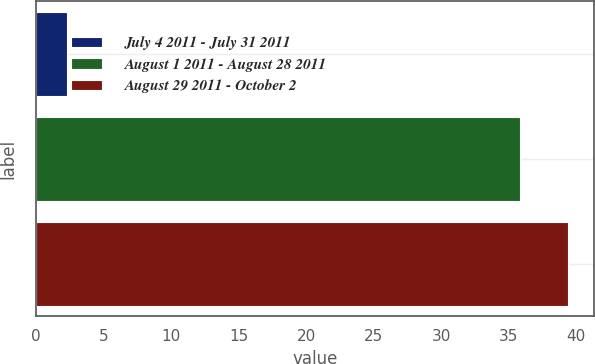Convert chart. <chart><loc_0><loc_0><loc_500><loc_500><bar_chart><fcel>July 4 2011 - July 31 2011<fcel>August 1 2011 - August 28 2011<fcel>August 29 2011 - October 2<nl><fcel>2.31<fcel>35.86<fcel>39.37<nl></chart> 